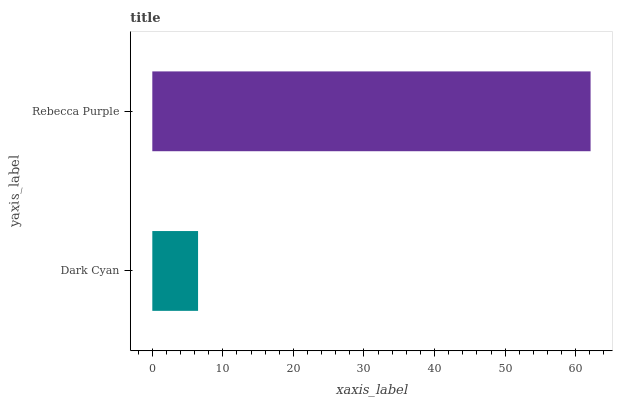Is Dark Cyan the minimum?
Answer yes or no. Yes. Is Rebecca Purple the maximum?
Answer yes or no. Yes. Is Rebecca Purple the minimum?
Answer yes or no. No. Is Rebecca Purple greater than Dark Cyan?
Answer yes or no. Yes. Is Dark Cyan less than Rebecca Purple?
Answer yes or no. Yes. Is Dark Cyan greater than Rebecca Purple?
Answer yes or no. No. Is Rebecca Purple less than Dark Cyan?
Answer yes or no. No. Is Rebecca Purple the high median?
Answer yes or no. Yes. Is Dark Cyan the low median?
Answer yes or no. Yes. Is Dark Cyan the high median?
Answer yes or no. No. Is Rebecca Purple the low median?
Answer yes or no. No. 